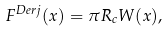<formula> <loc_0><loc_0><loc_500><loc_500>F ^ { D e r j } ( x ) = \pi R _ { c } W ( x ) ,</formula> 